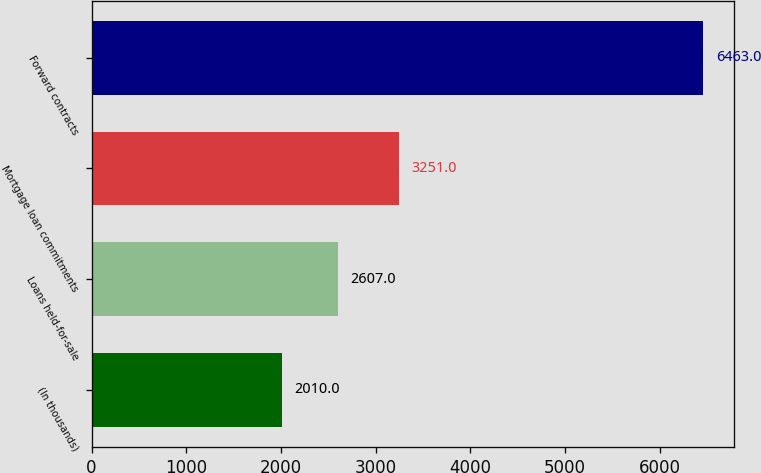Convert chart to OTSL. <chart><loc_0><loc_0><loc_500><loc_500><bar_chart><fcel>(In thousands)<fcel>Loans held-for-sale<fcel>Mortgage loan commitments<fcel>Forward contracts<nl><fcel>2010<fcel>2607<fcel>3251<fcel>6463<nl></chart> 